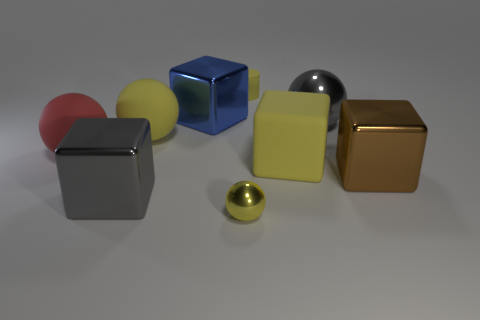There is a thing that is the same color as the big shiny ball; what is its shape? cube 